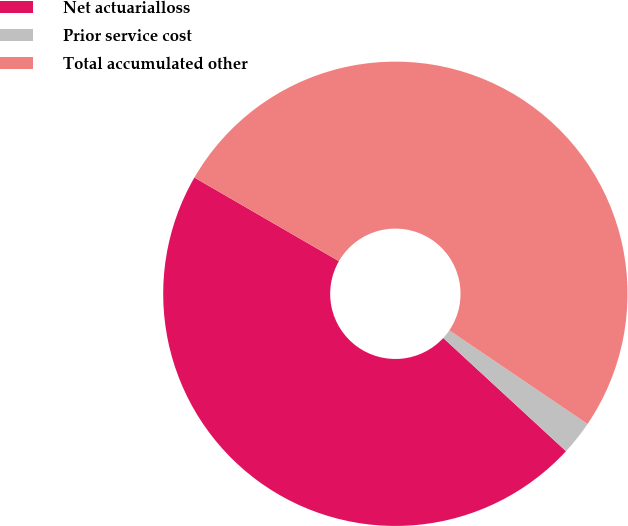Convert chart. <chart><loc_0><loc_0><loc_500><loc_500><pie_chart><fcel>Net actuarialloss<fcel>Prior service cost<fcel>Total accumulated other<nl><fcel>46.49%<fcel>2.38%<fcel>51.13%<nl></chart> 